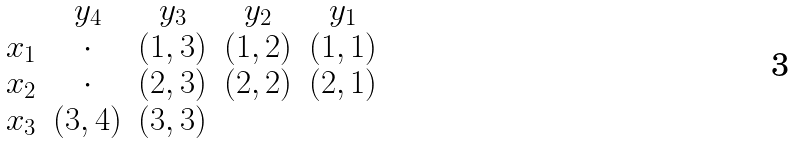<formula> <loc_0><loc_0><loc_500><loc_500>\begin{matrix} & y _ { 4 } & y _ { 3 } & y _ { 2 } & y _ { 1 } \\ x _ { 1 } & \cdot & ( 1 , 3 ) & ( 1 , 2 ) & ( 1 , 1 ) \\ x _ { 2 } & \cdot & ( 2 , 3 ) & ( 2 , 2 ) & ( 2 , 1 ) \\ x _ { 3 } & ( 3 , 4 ) & ( 3 , 3 ) & & \end{matrix}</formula> 